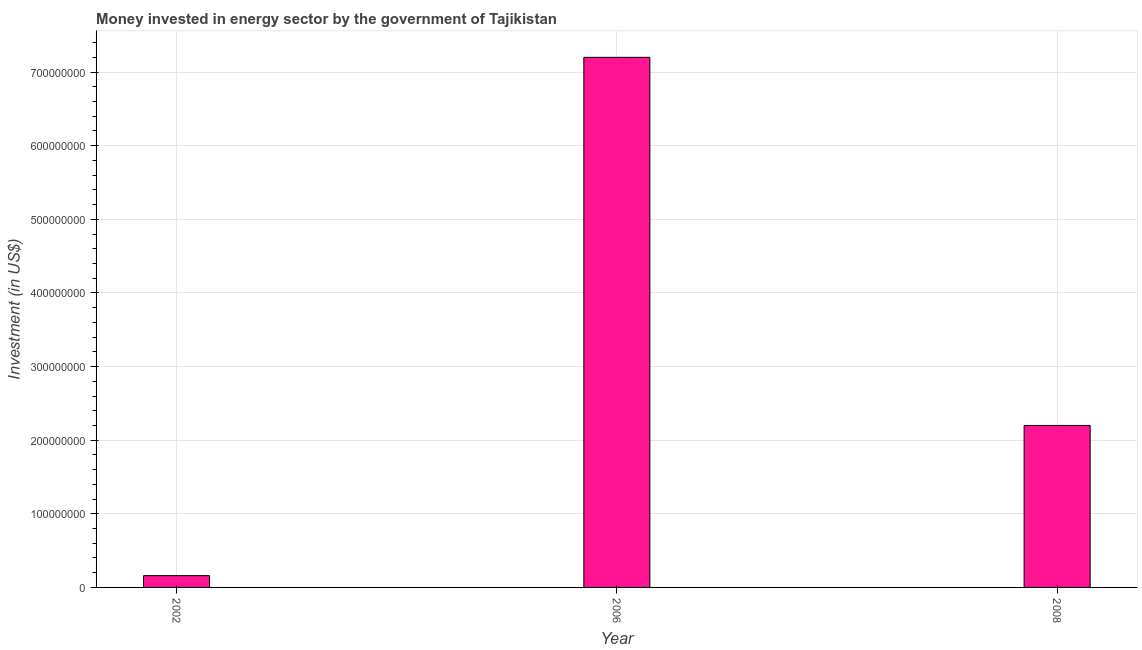What is the title of the graph?
Make the answer very short. Money invested in energy sector by the government of Tajikistan. What is the label or title of the Y-axis?
Keep it short and to the point. Investment (in US$). What is the investment in energy in 2006?
Provide a short and direct response. 7.20e+08. Across all years, what is the maximum investment in energy?
Offer a very short reply. 7.20e+08. Across all years, what is the minimum investment in energy?
Provide a short and direct response. 1.60e+07. In which year was the investment in energy minimum?
Offer a terse response. 2002. What is the sum of the investment in energy?
Offer a terse response. 9.56e+08. What is the difference between the investment in energy in 2002 and 2008?
Offer a terse response. -2.04e+08. What is the average investment in energy per year?
Your response must be concise. 3.19e+08. What is the median investment in energy?
Offer a terse response. 2.20e+08. What is the ratio of the investment in energy in 2002 to that in 2008?
Your response must be concise. 0.07. Is the investment in energy in 2002 less than that in 2006?
Make the answer very short. Yes. Is the difference between the investment in energy in 2006 and 2008 greater than the difference between any two years?
Offer a very short reply. No. What is the difference between the highest and the lowest investment in energy?
Make the answer very short. 7.04e+08. How many bars are there?
Keep it short and to the point. 3. Are all the bars in the graph horizontal?
Offer a terse response. No. How many years are there in the graph?
Keep it short and to the point. 3. What is the difference between two consecutive major ticks on the Y-axis?
Your response must be concise. 1.00e+08. What is the Investment (in US$) in 2002?
Your answer should be very brief. 1.60e+07. What is the Investment (in US$) in 2006?
Your answer should be very brief. 7.20e+08. What is the Investment (in US$) of 2008?
Offer a terse response. 2.20e+08. What is the difference between the Investment (in US$) in 2002 and 2006?
Offer a very short reply. -7.04e+08. What is the difference between the Investment (in US$) in 2002 and 2008?
Offer a terse response. -2.04e+08. What is the ratio of the Investment (in US$) in 2002 to that in 2006?
Your answer should be very brief. 0.02. What is the ratio of the Investment (in US$) in 2002 to that in 2008?
Make the answer very short. 0.07. What is the ratio of the Investment (in US$) in 2006 to that in 2008?
Your answer should be very brief. 3.27. 